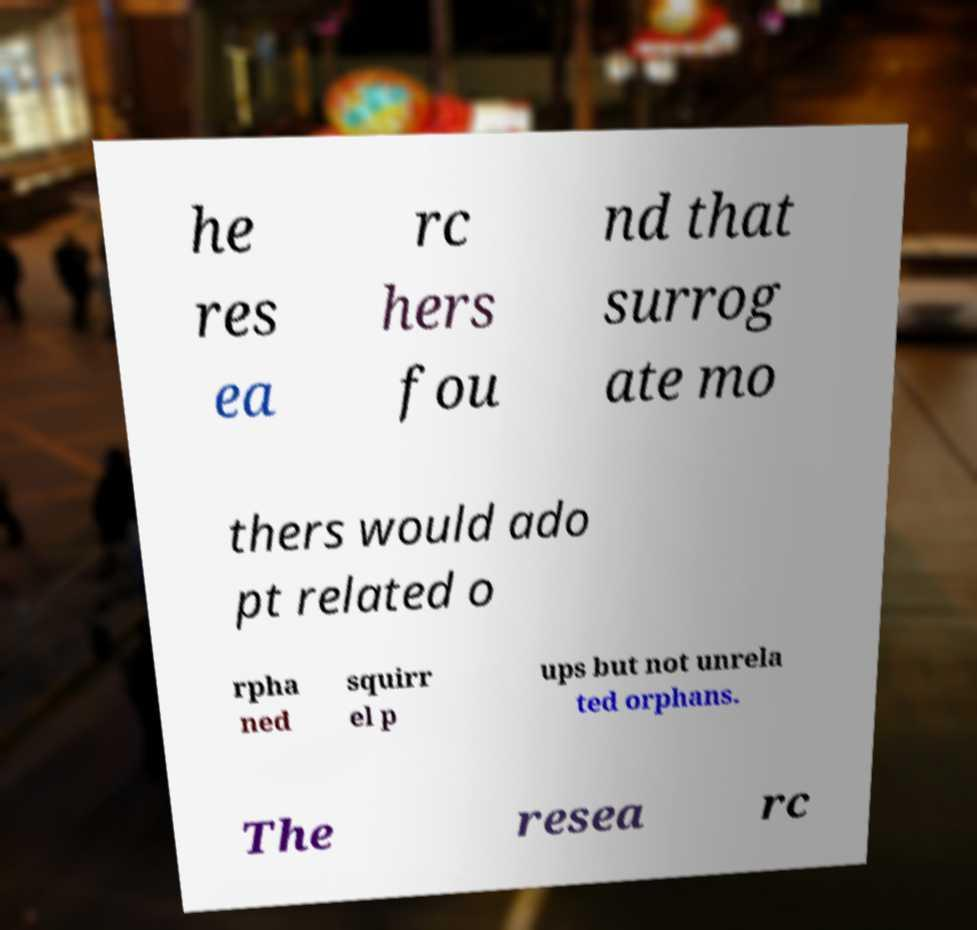What messages or text are displayed in this image? I need them in a readable, typed format. he res ea rc hers fou nd that surrog ate mo thers would ado pt related o rpha ned squirr el p ups but not unrela ted orphans. The resea rc 